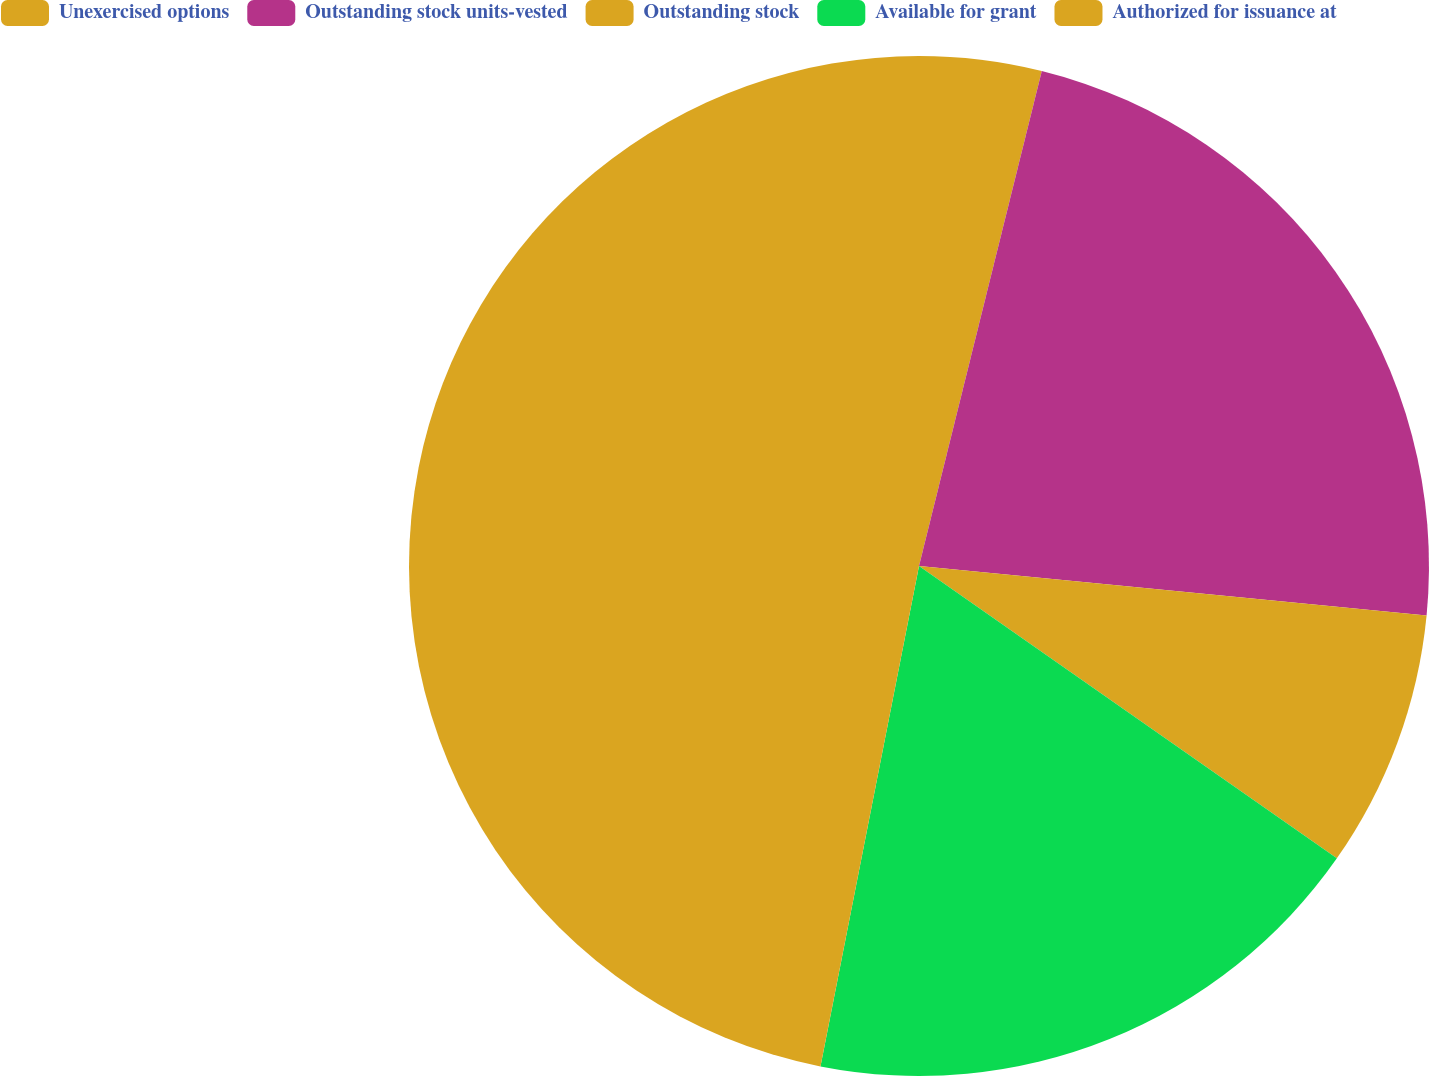Convert chart to OTSL. <chart><loc_0><loc_0><loc_500><loc_500><pie_chart><fcel>Unexercised options<fcel>Outstanding stock units-vested<fcel>Outstanding stock<fcel>Available for grant<fcel>Authorized for issuance at<nl><fcel>3.87%<fcel>22.68%<fcel>8.17%<fcel>18.38%<fcel>46.91%<nl></chart> 